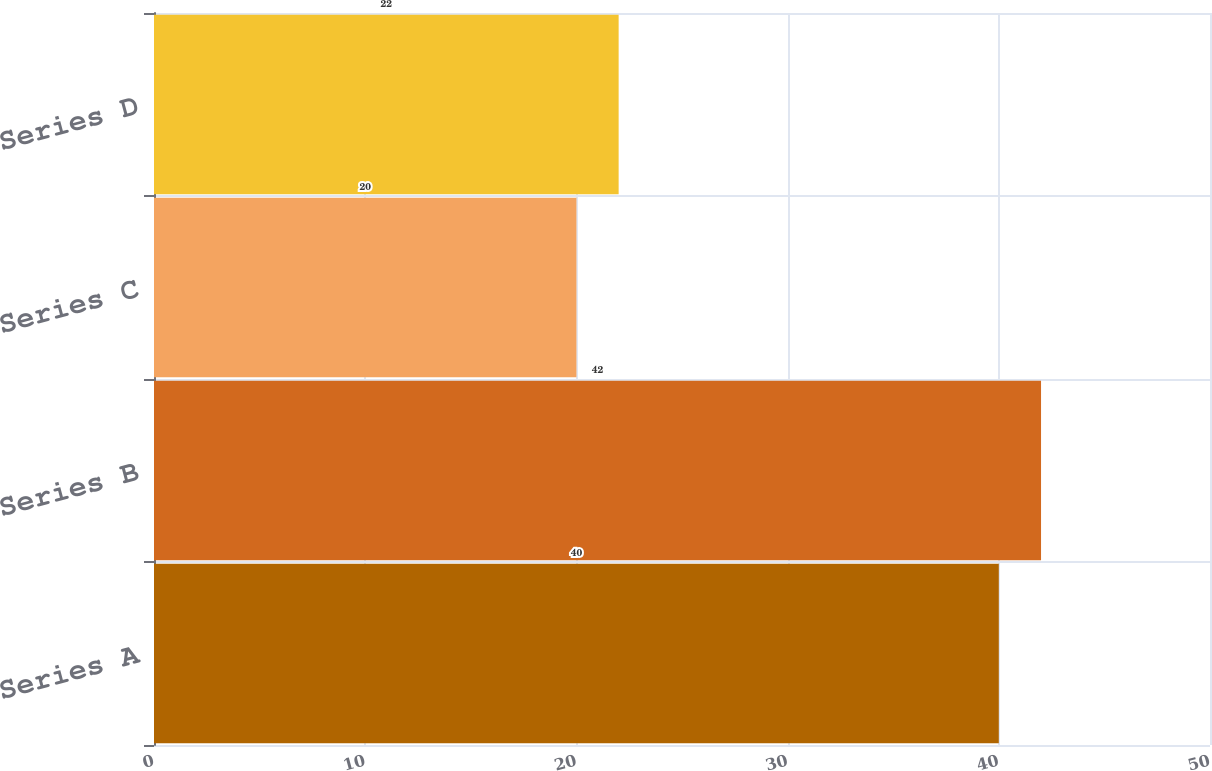Convert chart. <chart><loc_0><loc_0><loc_500><loc_500><bar_chart><fcel>Series A<fcel>Series B<fcel>Series C<fcel>Series D<nl><fcel>40<fcel>42<fcel>20<fcel>22<nl></chart> 